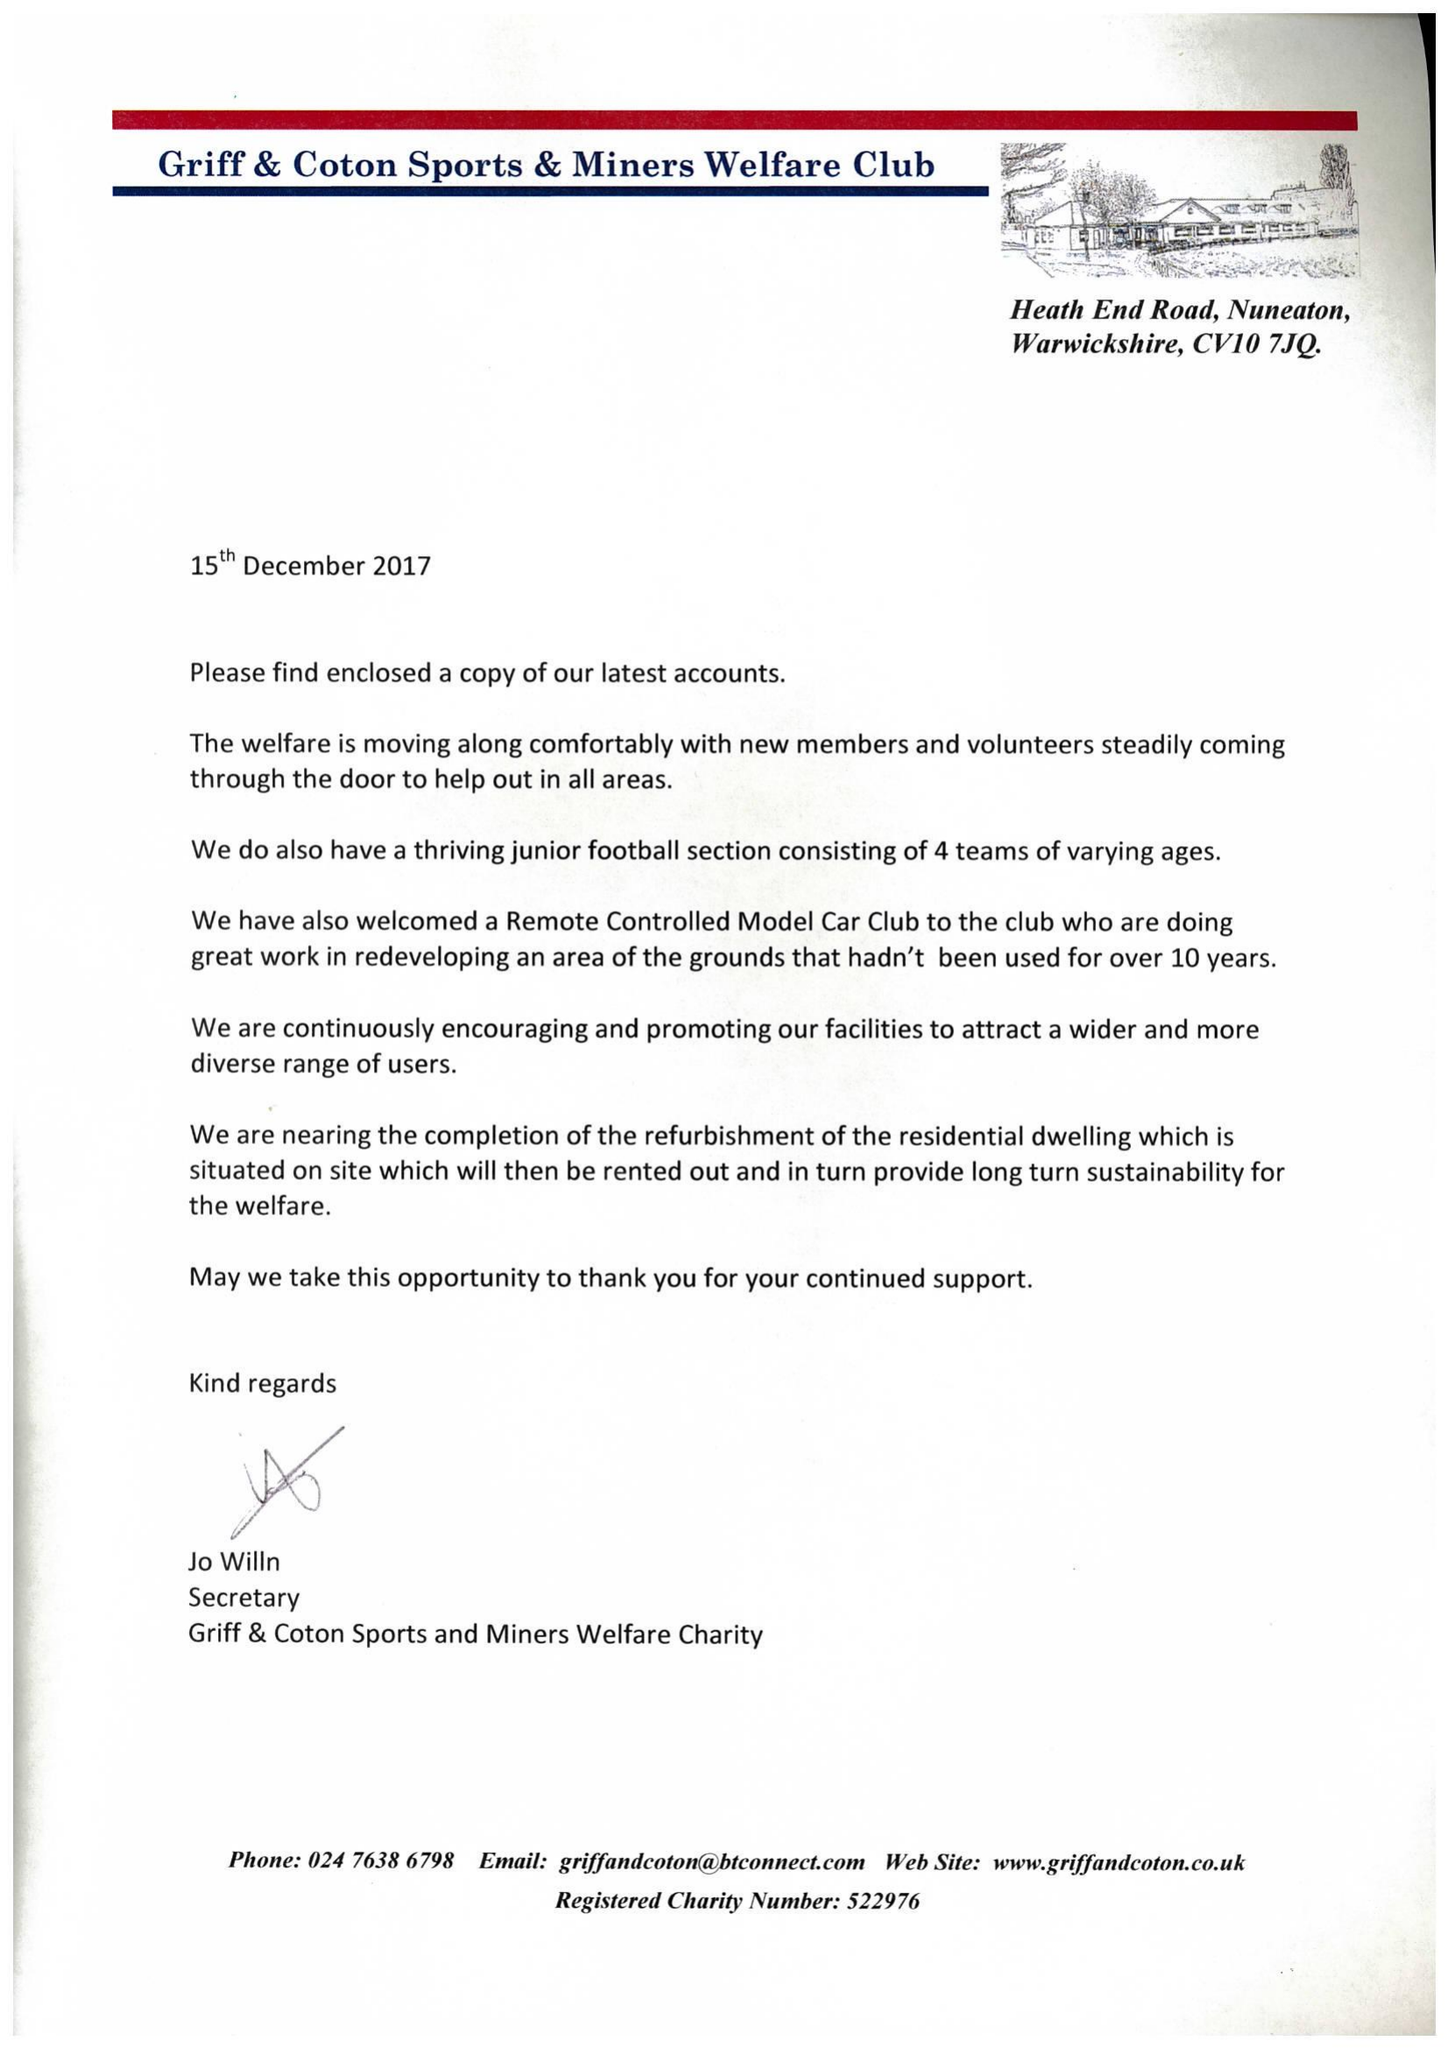What is the value for the income_annually_in_british_pounds?
Answer the question using a single word or phrase. 241647.00 